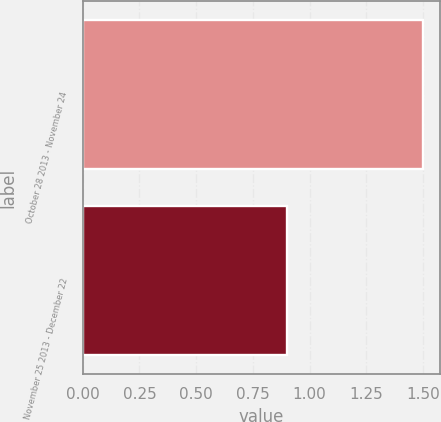Convert chart. <chart><loc_0><loc_0><loc_500><loc_500><bar_chart><fcel>October 28 2013 - November 24<fcel>November 25 2013 - December 22<nl><fcel>1.5<fcel>0.9<nl></chart> 